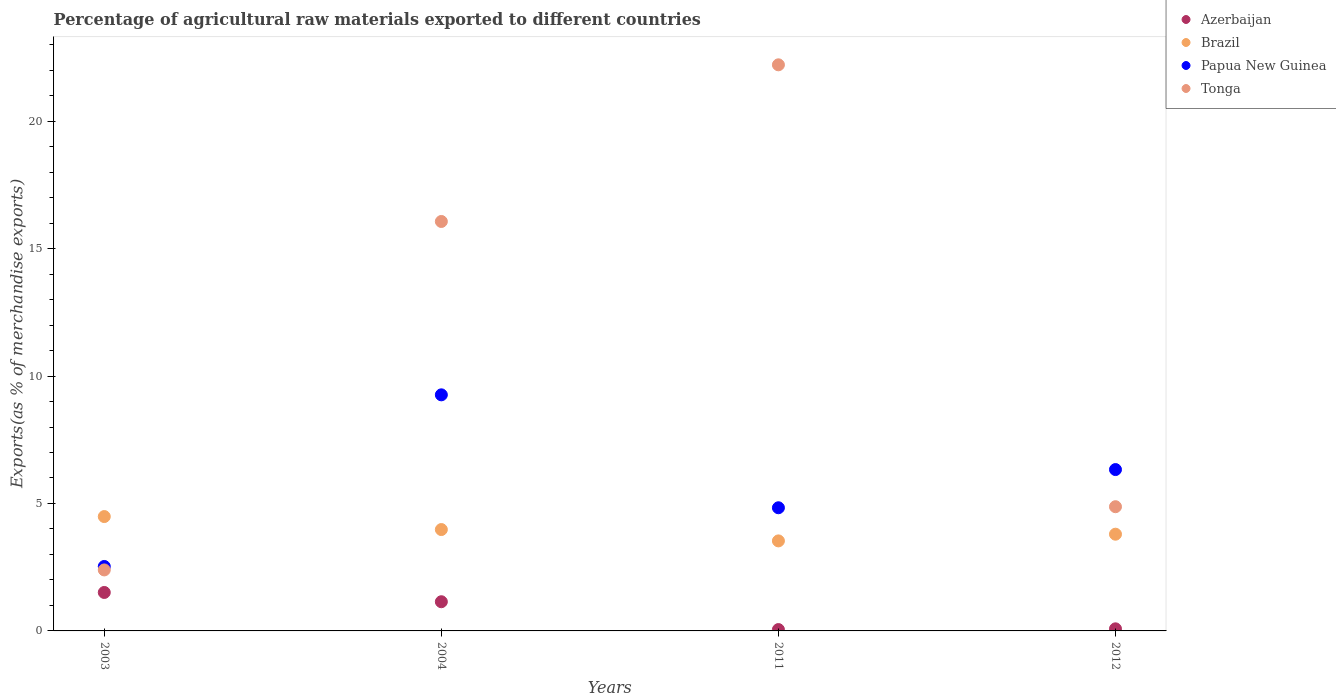What is the percentage of exports to different countries in Brazil in 2004?
Your response must be concise. 3.98. Across all years, what is the maximum percentage of exports to different countries in Papua New Guinea?
Offer a very short reply. 9.26. Across all years, what is the minimum percentage of exports to different countries in Azerbaijan?
Provide a short and direct response. 0.05. In which year was the percentage of exports to different countries in Papua New Guinea maximum?
Keep it short and to the point. 2004. What is the total percentage of exports to different countries in Tonga in the graph?
Keep it short and to the point. 45.54. What is the difference between the percentage of exports to different countries in Azerbaijan in 2003 and that in 2011?
Keep it short and to the point. 1.46. What is the difference between the percentage of exports to different countries in Tonga in 2004 and the percentage of exports to different countries in Brazil in 2011?
Your answer should be compact. 12.53. What is the average percentage of exports to different countries in Papua New Guinea per year?
Your response must be concise. 5.74. In the year 2004, what is the difference between the percentage of exports to different countries in Azerbaijan and percentage of exports to different countries in Papua New Guinea?
Make the answer very short. -8.12. What is the ratio of the percentage of exports to different countries in Tonga in 2004 to that in 2011?
Provide a succinct answer. 0.72. Is the difference between the percentage of exports to different countries in Azerbaijan in 2003 and 2004 greater than the difference between the percentage of exports to different countries in Papua New Guinea in 2003 and 2004?
Give a very brief answer. Yes. What is the difference between the highest and the second highest percentage of exports to different countries in Tonga?
Offer a very short reply. 6.15. What is the difference between the highest and the lowest percentage of exports to different countries in Brazil?
Your answer should be very brief. 0.95. In how many years, is the percentage of exports to different countries in Brazil greater than the average percentage of exports to different countries in Brazil taken over all years?
Give a very brief answer. 2. Is it the case that in every year, the sum of the percentage of exports to different countries in Tonga and percentage of exports to different countries in Azerbaijan  is greater than the sum of percentage of exports to different countries in Brazil and percentage of exports to different countries in Papua New Guinea?
Your response must be concise. No. Is it the case that in every year, the sum of the percentage of exports to different countries in Papua New Guinea and percentage of exports to different countries in Azerbaijan  is greater than the percentage of exports to different countries in Brazil?
Offer a terse response. No. Does the percentage of exports to different countries in Azerbaijan monotonically increase over the years?
Ensure brevity in your answer.  No. Is the percentage of exports to different countries in Papua New Guinea strictly greater than the percentage of exports to different countries in Azerbaijan over the years?
Provide a short and direct response. Yes. Is the percentage of exports to different countries in Papua New Guinea strictly less than the percentage of exports to different countries in Azerbaijan over the years?
Provide a succinct answer. No. How many years are there in the graph?
Your answer should be compact. 4. Does the graph contain grids?
Keep it short and to the point. No. Where does the legend appear in the graph?
Your answer should be compact. Top right. How are the legend labels stacked?
Give a very brief answer. Vertical. What is the title of the graph?
Make the answer very short. Percentage of agricultural raw materials exported to different countries. What is the label or title of the X-axis?
Provide a succinct answer. Years. What is the label or title of the Y-axis?
Offer a terse response. Exports(as % of merchandise exports). What is the Exports(as % of merchandise exports) of Azerbaijan in 2003?
Offer a very short reply. 1.51. What is the Exports(as % of merchandise exports) of Brazil in 2003?
Your response must be concise. 4.49. What is the Exports(as % of merchandise exports) of Papua New Guinea in 2003?
Your answer should be compact. 2.53. What is the Exports(as % of merchandise exports) in Tonga in 2003?
Your answer should be very brief. 2.39. What is the Exports(as % of merchandise exports) of Azerbaijan in 2004?
Ensure brevity in your answer.  1.15. What is the Exports(as % of merchandise exports) in Brazil in 2004?
Ensure brevity in your answer.  3.98. What is the Exports(as % of merchandise exports) in Papua New Guinea in 2004?
Your answer should be compact. 9.26. What is the Exports(as % of merchandise exports) in Tonga in 2004?
Offer a very short reply. 16.06. What is the Exports(as % of merchandise exports) of Azerbaijan in 2011?
Your answer should be compact. 0.05. What is the Exports(as % of merchandise exports) in Brazil in 2011?
Your answer should be very brief. 3.53. What is the Exports(as % of merchandise exports) in Papua New Guinea in 2011?
Keep it short and to the point. 4.83. What is the Exports(as % of merchandise exports) in Tonga in 2011?
Provide a short and direct response. 22.21. What is the Exports(as % of merchandise exports) of Azerbaijan in 2012?
Give a very brief answer. 0.08. What is the Exports(as % of merchandise exports) in Brazil in 2012?
Your answer should be compact. 3.79. What is the Exports(as % of merchandise exports) of Papua New Guinea in 2012?
Keep it short and to the point. 6.33. What is the Exports(as % of merchandise exports) in Tonga in 2012?
Make the answer very short. 4.87. Across all years, what is the maximum Exports(as % of merchandise exports) in Azerbaijan?
Offer a very short reply. 1.51. Across all years, what is the maximum Exports(as % of merchandise exports) of Brazil?
Keep it short and to the point. 4.49. Across all years, what is the maximum Exports(as % of merchandise exports) of Papua New Guinea?
Ensure brevity in your answer.  9.26. Across all years, what is the maximum Exports(as % of merchandise exports) in Tonga?
Provide a short and direct response. 22.21. Across all years, what is the minimum Exports(as % of merchandise exports) of Azerbaijan?
Ensure brevity in your answer.  0.05. Across all years, what is the minimum Exports(as % of merchandise exports) of Brazil?
Give a very brief answer. 3.53. Across all years, what is the minimum Exports(as % of merchandise exports) in Papua New Guinea?
Make the answer very short. 2.53. Across all years, what is the minimum Exports(as % of merchandise exports) in Tonga?
Offer a terse response. 2.39. What is the total Exports(as % of merchandise exports) of Azerbaijan in the graph?
Offer a very short reply. 2.79. What is the total Exports(as % of merchandise exports) of Brazil in the graph?
Your answer should be compact. 15.79. What is the total Exports(as % of merchandise exports) of Papua New Guinea in the graph?
Ensure brevity in your answer.  22.95. What is the total Exports(as % of merchandise exports) of Tonga in the graph?
Your response must be concise. 45.54. What is the difference between the Exports(as % of merchandise exports) in Azerbaijan in 2003 and that in 2004?
Give a very brief answer. 0.36. What is the difference between the Exports(as % of merchandise exports) in Brazil in 2003 and that in 2004?
Make the answer very short. 0.51. What is the difference between the Exports(as % of merchandise exports) of Papua New Guinea in 2003 and that in 2004?
Provide a succinct answer. -6.73. What is the difference between the Exports(as % of merchandise exports) of Tonga in 2003 and that in 2004?
Your answer should be compact. -13.67. What is the difference between the Exports(as % of merchandise exports) of Azerbaijan in 2003 and that in 2011?
Provide a succinct answer. 1.46. What is the difference between the Exports(as % of merchandise exports) of Brazil in 2003 and that in 2011?
Your answer should be compact. 0.95. What is the difference between the Exports(as % of merchandise exports) of Papua New Guinea in 2003 and that in 2011?
Provide a succinct answer. -2.3. What is the difference between the Exports(as % of merchandise exports) in Tonga in 2003 and that in 2011?
Offer a very short reply. -19.82. What is the difference between the Exports(as % of merchandise exports) of Azerbaijan in 2003 and that in 2012?
Offer a very short reply. 1.43. What is the difference between the Exports(as % of merchandise exports) in Brazil in 2003 and that in 2012?
Provide a short and direct response. 0.69. What is the difference between the Exports(as % of merchandise exports) of Papua New Guinea in 2003 and that in 2012?
Offer a terse response. -3.8. What is the difference between the Exports(as % of merchandise exports) in Tonga in 2003 and that in 2012?
Offer a terse response. -2.48. What is the difference between the Exports(as % of merchandise exports) of Azerbaijan in 2004 and that in 2011?
Your answer should be compact. 1.09. What is the difference between the Exports(as % of merchandise exports) in Brazil in 2004 and that in 2011?
Your answer should be compact. 0.45. What is the difference between the Exports(as % of merchandise exports) of Papua New Guinea in 2004 and that in 2011?
Make the answer very short. 4.43. What is the difference between the Exports(as % of merchandise exports) in Tonga in 2004 and that in 2011?
Offer a terse response. -6.15. What is the difference between the Exports(as % of merchandise exports) of Azerbaijan in 2004 and that in 2012?
Make the answer very short. 1.06. What is the difference between the Exports(as % of merchandise exports) in Brazil in 2004 and that in 2012?
Offer a very short reply. 0.18. What is the difference between the Exports(as % of merchandise exports) of Papua New Guinea in 2004 and that in 2012?
Your response must be concise. 2.93. What is the difference between the Exports(as % of merchandise exports) of Tonga in 2004 and that in 2012?
Give a very brief answer. 11.19. What is the difference between the Exports(as % of merchandise exports) in Azerbaijan in 2011 and that in 2012?
Provide a succinct answer. -0.03. What is the difference between the Exports(as % of merchandise exports) in Brazil in 2011 and that in 2012?
Your answer should be compact. -0.26. What is the difference between the Exports(as % of merchandise exports) of Papua New Guinea in 2011 and that in 2012?
Provide a short and direct response. -1.5. What is the difference between the Exports(as % of merchandise exports) in Tonga in 2011 and that in 2012?
Keep it short and to the point. 17.34. What is the difference between the Exports(as % of merchandise exports) in Azerbaijan in 2003 and the Exports(as % of merchandise exports) in Brazil in 2004?
Make the answer very short. -2.47. What is the difference between the Exports(as % of merchandise exports) of Azerbaijan in 2003 and the Exports(as % of merchandise exports) of Papua New Guinea in 2004?
Your answer should be very brief. -7.75. What is the difference between the Exports(as % of merchandise exports) of Azerbaijan in 2003 and the Exports(as % of merchandise exports) of Tonga in 2004?
Offer a very short reply. -14.56. What is the difference between the Exports(as % of merchandise exports) of Brazil in 2003 and the Exports(as % of merchandise exports) of Papua New Guinea in 2004?
Keep it short and to the point. -4.78. What is the difference between the Exports(as % of merchandise exports) of Brazil in 2003 and the Exports(as % of merchandise exports) of Tonga in 2004?
Ensure brevity in your answer.  -11.58. What is the difference between the Exports(as % of merchandise exports) of Papua New Guinea in 2003 and the Exports(as % of merchandise exports) of Tonga in 2004?
Offer a very short reply. -13.54. What is the difference between the Exports(as % of merchandise exports) of Azerbaijan in 2003 and the Exports(as % of merchandise exports) of Brazil in 2011?
Your answer should be very brief. -2.02. What is the difference between the Exports(as % of merchandise exports) in Azerbaijan in 2003 and the Exports(as % of merchandise exports) in Papua New Guinea in 2011?
Ensure brevity in your answer.  -3.32. What is the difference between the Exports(as % of merchandise exports) of Azerbaijan in 2003 and the Exports(as % of merchandise exports) of Tonga in 2011?
Make the answer very short. -20.7. What is the difference between the Exports(as % of merchandise exports) in Brazil in 2003 and the Exports(as % of merchandise exports) in Papua New Guinea in 2011?
Keep it short and to the point. -0.35. What is the difference between the Exports(as % of merchandise exports) in Brazil in 2003 and the Exports(as % of merchandise exports) in Tonga in 2011?
Ensure brevity in your answer.  -17.72. What is the difference between the Exports(as % of merchandise exports) in Papua New Guinea in 2003 and the Exports(as % of merchandise exports) in Tonga in 2011?
Give a very brief answer. -19.68. What is the difference between the Exports(as % of merchandise exports) of Azerbaijan in 2003 and the Exports(as % of merchandise exports) of Brazil in 2012?
Offer a very short reply. -2.29. What is the difference between the Exports(as % of merchandise exports) of Azerbaijan in 2003 and the Exports(as % of merchandise exports) of Papua New Guinea in 2012?
Make the answer very short. -4.82. What is the difference between the Exports(as % of merchandise exports) of Azerbaijan in 2003 and the Exports(as % of merchandise exports) of Tonga in 2012?
Your answer should be compact. -3.36. What is the difference between the Exports(as % of merchandise exports) of Brazil in 2003 and the Exports(as % of merchandise exports) of Papua New Guinea in 2012?
Make the answer very short. -1.84. What is the difference between the Exports(as % of merchandise exports) in Brazil in 2003 and the Exports(as % of merchandise exports) in Tonga in 2012?
Keep it short and to the point. -0.39. What is the difference between the Exports(as % of merchandise exports) in Papua New Guinea in 2003 and the Exports(as % of merchandise exports) in Tonga in 2012?
Your answer should be very brief. -2.34. What is the difference between the Exports(as % of merchandise exports) in Azerbaijan in 2004 and the Exports(as % of merchandise exports) in Brazil in 2011?
Your response must be concise. -2.39. What is the difference between the Exports(as % of merchandise exports) of Azerbaijan in 2004 and the Exports(as % of merchandise exports) of Papua New Guinea in 2011?
Make the answer very short. -3.69. What is the difference between the Exports(as % of merchandise exports) of Azerbaijan in 2004 and the Exports(as % of merchandise exports) of Tonga in 2011?
Your answer should be compact. -21.07. What is the difference between the Exports(as % of merchandise exports) in Brazil in 2004 and the Exports(as % of merchandise exports) in Papua New Guinea in 2011?
Provide a succinct answer. -0.85. What is the difference between the Exports(as % of merchandise exports) in Brazil in 2004 and the Exports(as % of merchandise exports) in Tonga in 2011?
Your answer should be very brief. -18.23. What is the difference between the Exports(as % of merchandise exports) in Papua New Guinea in 2004 and the Exports(as % of merchandise exports) in Tonga in 2011?
Your answer should be compact. -12.95. What is the difference between the Exports(as % of merchandise exports) in Azerbaijan in 2004 and the Exports(as % of merchandise exports) in Brazil in 2012?
Your answer should be very brief. -2.65. What is the difference between the Exports(as % of merchandise exports) in Azerbaijan in 2004 and the Exports(as % of merchandise exports) in Papua New Guinea in 2012?
Provide a short and direct response. -5.19. What is the difference between the Exports(as % of merchandise exports) of Azerbaijan in 2004 and the Exports(as % of merchandise exports) of Tonga in 2012?
Provide a succinct answer. -3.73. What is the difference between the Exports(as % of merchandise exports) in Brazil in 2004 and the Exports(as % of merchandise exports) in Papua New Guinea in 2012?
Make the answer very short. -2.35. What is the difference between the Exports(as % of merchandise exports) of Brazil in 2004 and the Exports(as % of merchandise exports) of Tonga in 2012?
Provide a short and direct response. -0.9. What is the difference between the Exports(as % of merchandise exports) in Papua New Guinea in 2004 and the Exports(as % of merchandise exports) in Tonga in 2012?
Provide a short and direct response. 4.39. What is the difference between the Exports(as % of merchandise exports) of Azerbaijan in 2011 and the Exports(as % of merchandise exports) of Brazil in 2012?
Provide a succinct answer. -3.74. What is the difference between the Exports(as % of merchandise exports) of Azerbaijan in 2011 and the Exports(as % of merchandise exports) of Papua New Guinea in 2012?
Provide a short and direct response. -6.28. What is the difference between the Exports(as % of merchandise exports) of Azerbaijan in 2011 and the Exports(as % of merchandise exports) of Tonga in 2012?
Give a very brief answer. -4.82. What is the difference between the Exports(as % of merchandise exports) of Brazil in 2011 and the Exports(as % of merchandise exports) of Papua New Guinea in 2012?
Make the answer very short. -2.8. What is the difference between the Exports(as % of merchandise exports) in Brazil in 2011 and the Exports(as % of merchandise exports) in Tonga in 2012?
Give a very brief answer. -1.34. What is the difference between the Exports(as % of merchandise exports) in Papua New Guinea in 2011 and the Exports(as % of merchandise exports) in Tonga in 2012?
Ensure brevity in your answer.  -0.04. What is the average Exports(as % of merchandise exports) in Azerbaijan per year?
Ensure brevity in your answer.  0.7. What is the average Exports(as % of merchandise exports) in Brazil per year?
Give a very brief answer. 3.95. What is the average Exports(as % of merchandise exports) in Papua New Guinea per year?
Provide a short and direct response. 5.74. What is the average Exports(as % of merchandise exports) of Tonga per year?
Ensure brevity in your answer.  11.39. In the year 2003, what is the difference between the Exports(as % of merchandise exports) in Azerbaijan and Exports(as % of merchandise exports) in Brazil?
Offer a very short reply. -2.98. In the year 2003, what is the difference between the Exports(as % of merchandise exports) in Azerbaijan and Exports(as % of merchandise exports) in Papua New Guinea?
Your answer should be very brief. -1.02. In the year 2003, what is the difference between the Exports(as % of merchandise exports) of Azerbaijan and Exports(as % of merchandise exports) of Tonga?
Offer a terse response. -0.88. In the year 2003, what is the difference between the Exports(as % of merchandise exports) in Brazil and Exports(as % of merchandise exports) in Papua New Guinea?
Give a very brief answer. 1.96. In the year 2003, what is the difference between the Exports(as % of merchandise exports) of Brazil and Exports(as % of merchandise exports) of Tonga?
Provide a succinct answer. 2.09. In the year 2003, what is the difference between the Exports(as % of merchandise exports) of Papua New Guinea and Exports(as % of merchandise exports) of Tonga?
Your response must be concise. 0.14. In the year 2004, what is the difference between the Exports(as % of merchandise exports) of Azerbaijan and Exports(as % of merchandise exports) of Brazil?
Offer a terse response. -2.83. In the year 2004, what is the difference between the Exports(as % of merchandise exports) of Azerbaijan and Exports(as % of merchandise exports) of Papua New Guinea?
Offer a very short reply. -8.12. In the year 2004, what is the difference between the Exports(as % of merchandise exports) of Azerbaijan and Exports(as % of merchandise exports) of Tonga?
Keep it short and to the point. -14.92. In the year 2004, what is the difference between the Exports(as % of merchandise exports) in Brazil and Exports(as % of merchandise exports) in Papua New Guinea?
Your answer should be very brief. -5.29. In the year 2004, what is the difference between the Exports(as % of merchandise exports) of Brazil and Exports(as % of merchandise exports) of Tonga?
Provide a short and direct response. -12.09. In the year 2004, what is the difference between the Exports(as % of merchandise exports) of Papua New Guinea and Exports(as % of merchandise exports) of Tonga?
Keep it short and to the point. -6.8. In the year 2011, what is the difference between the Exports(as % of merchandise exports) in Azerbaijan and Exports(as % of merchandise exports) in Brazil?
Offer a terse response. -3.48. In the year 2011, what is the difference between the Exports(as % of merchandise exports) of Azerbaijan and Exports(as % of merchandise exports) of Papua New Guinea?
Offer a terse response. -4.78. In the year 2011, what is the difference between the Exports(as % of merchandise exports) in Azerbaijan and Exports(as % of merchandise exports) in Tonga?
Your answer should be very brief. -22.16. In the year 2011, what is the difference between the Exports(as % of merchandise exports) of Brazil and Exports(as % of merchandise exports) of Papua New Guinea?
Your answer should be very brief. -1.3. In the year 2011, what is the difference between the Exports(as % of merchandise exports) of Brazil and Exports(as % of merchandise exports) of Tonga?
Ensure brevity in your answer.  -18.68. In the year 2011, what is the difference between the Exports(as % of merchandise exports) of Papua New Guinea and Exports(as % of merchandise exports) of Tonga?
Your answer should be very brief. -17.38. In the year 2012, what is the difference between the Exports(as % of merchandise exports) in Azerbaijan and Exports(as % of merchandise exports) in Brazil?
Your answer should be compact. -3.71. In the year 2012, what is the difference between the Exports(as % of merchandise exports) in Azerbaijan and Exports(as % of merchandise exports) in Papua New Guinea?
Your answer should be very brief. -6.25. In the year 2012, what is the difference between the Exports(as % of merchandise exports) in Azerbaijan and Exports(as % of merchandise exports) in Tonga?
Keep it short and to the point. -4.79. In the year 2012, what is the difference between the Exports(as % of merchandise exports) in Brazil and Exports(as % of merchandise exports) in Papua New Guinea?
Ensure brevity in your answer.  -2.54. In the year 2012, what is the difference between the Exports(as % of merchandise exports) in Brazil and Exports(as % of merchandise exports) in Tonga?
Provide a succinct answer. -1.08. In the year 2012, what is the difference between the Exports(as % of merchandise exports) of Papua New Guinea and Exports(as % of merchandise exports) of Tonga?
Your answer should be very brief. 1.46. What is the ratio of the Exports(as % of merchandise exports) in Azerbaijan in 2003 to that in 2004?
Make the answer very short. 1.32. What is the ratio of the Exports(as % of merchandise exports) in Brazil in 2003 to that in 2004?
Give a very brief answer. 1.13. What is the ratio of the Exports(as % of merchandise exports) in Papua New Guinea in 2003 to that in 2004?
Your answer should be compact. 0.27. What is the ratio of the Exports(as % of merchandise exports) in Tonga in 2003 to that in 2004?
Your answer should be compact. 0.15. What is the ratio of the Exports(as % of merchandise exports) of Azerbaijan in 2003 to that in 2011?
Your response must be concise. 28.44. What is the ratio of the Exports(as % of merchandise exports) of Brazil in 2003 to that in 2011?
Make the answer very short. 1.27. What is the ratio of the Exports(as % of merchandise exports) in Papua New Guinea in 2003 to that in 2011?
Your response must be concise. 0.52. What is the ratio of the Exports(as % of merchandise exports) of Tonga in 2003 to that in 2011?
Your answer should be very brief. 0.11. What is the ratio of the Exports(as % of merchandise exports) of Azerbaijan in 2003 to that in 2012?
Ensure brevity in your answer.  18.36. What is the ratio of the Exports(as % of merchandise exports) of Brazil in 2003 to that in 2012?
Offer a terse response. 1.18. What is the ratio of the Exports(as % of merchandise exports) in Papua New Guinea in 2003 to that in 2012?
Provide a succinct answer. 0.4. What is the ratio of the Exports(as % of merchandise exports) of Tonga in 2003 to that in 2012?
Offer a very short reply. 0.49. What is the ratio of the Exports(as % of merchandise exports) in Azerbaijan in 2004 to that in 2011?
Keep it short and to the point. 21.58. What is the ratio of the Exports(as % of merchandise exports) of Brazil in 2004 to that in 2011?
Make the answer very short. 1.13. What is the ratio of the Exports(as % of merchandise exports) in Papua New Guinea in 2004 to that in 2011?
Your answer should be very brief. 1.92. What is the ratio of the Exports(as % of merchandise exports) of Tonga in 2004 to that in 2011?
Provide a short and direct response. 0.72. What is the ratio of the Exports(as % of merchandise exports) of Azerbaijan in 2004 to that in 2012?
Make the answer very short. 13.93. What is the ratio of the Exports(as % of merchandise exports) of Brazil in 2004 to that in 2012?
Offer a very short reply. 1.05. What is the ratio of the Exports(as % of merchandise exports) in Papua New Guinea in 2004 to that in 2012?
Offer a very short reply. 1.46. What is the ratio of the Exports(as % of merchandise exports) of Tonga in 2004 to that in 2012?
Offer a terse response. 3.3. What is the ratio of the Exports(as % of merchandise exports) in Azerbaijan in 2011 to that in 2012?
Ensure brevity in your answer.  0.65. What is the ratio of the Exports(as % of merchandise exports) in Brazil in 2011 to that in 2012?
Keep it short and to the point. 0.93. What is the ratio of the Exports(as % of merchandise exports) in Papua New Guinea in 2011 to that in 2012?
Ensure brevity in your answer.  0.76. What is the ratio of the Exports(as % of merchandise exports) in Tonga in 2011 to that in 2012?
Your answer should be very brief. 4.56. What is the difference between the highest and the second highest Exports(as % of merchandise exports) of Azerbaijan?
Your answer should be very brief. 0.36. What is the difference between the highest and the second highest Exports(as % of merchandise exports) in Brazil?
Keep it short and to the point. 0.51. What is the difference between the highest and the second highest Exports(as % of merchandise exports) of Papua New Guinea?
Offer a terse response. 2.93. What is the difference between the highest and the second highest Exports(as % of merchandise exports) in Tonga?
Offer a very short reply. 6.15. What is the difference between the highest and the lowest Exports(as % of merchandise exports) in Azerbaijan?
Ensure brevity in your answer.  1.46. What is the difference between the highest and the lowest Exports(as % of merchandise exports) in Brazil?
Keep it short and to the point. 0.95. What is the difference between the highest and the lowest Exports(as % of merchandise exports) of Papua New Guinea?
Offer a terse response. 6.73. What is the difference between the highest and the lowest Exports(as % of merchandise exports) of Tonga?
Your response must be concise. 19.82. 